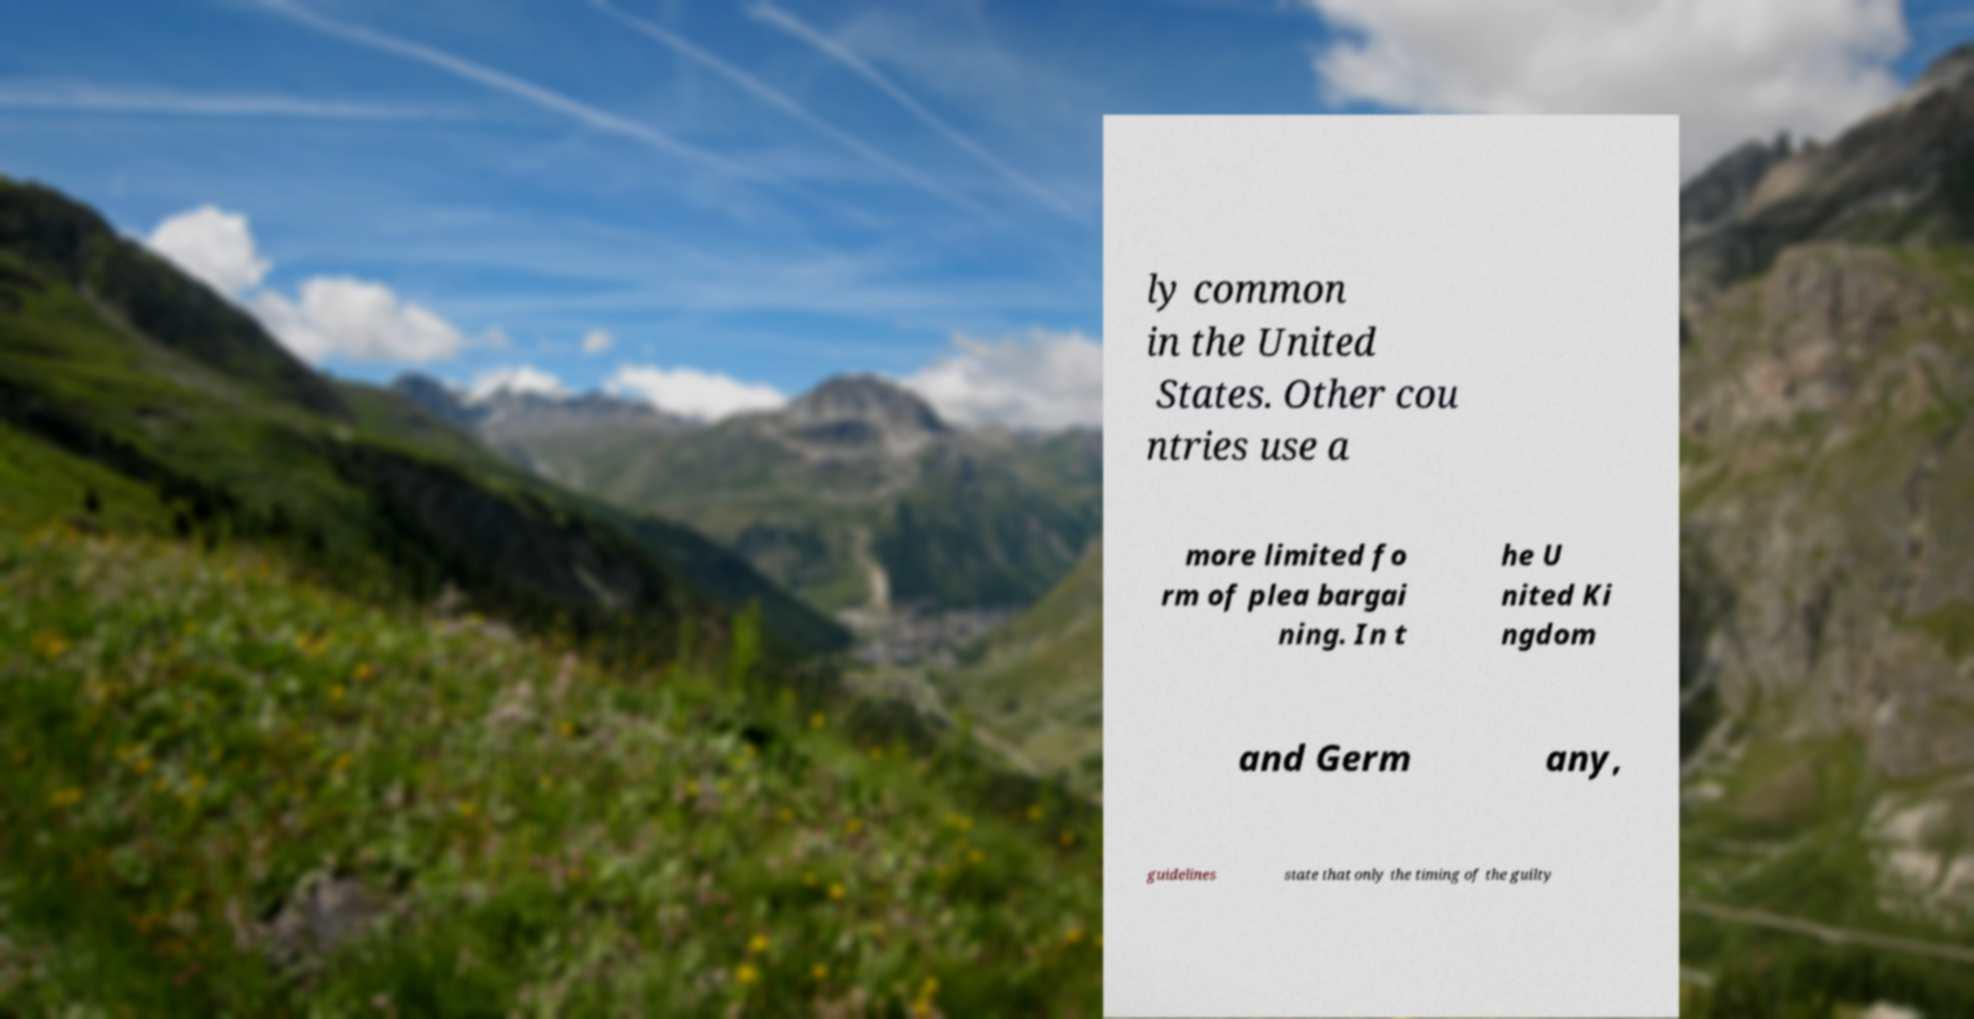There's text embedded in this image that I need extracted. Can you transcribe it verbatim? ly common in the United States. Other cou ntries use a more limited fo rm of plea bargai ning. In t he U nited Ki ngdom and Germ any, guidelines state that only the timing of the guilty 